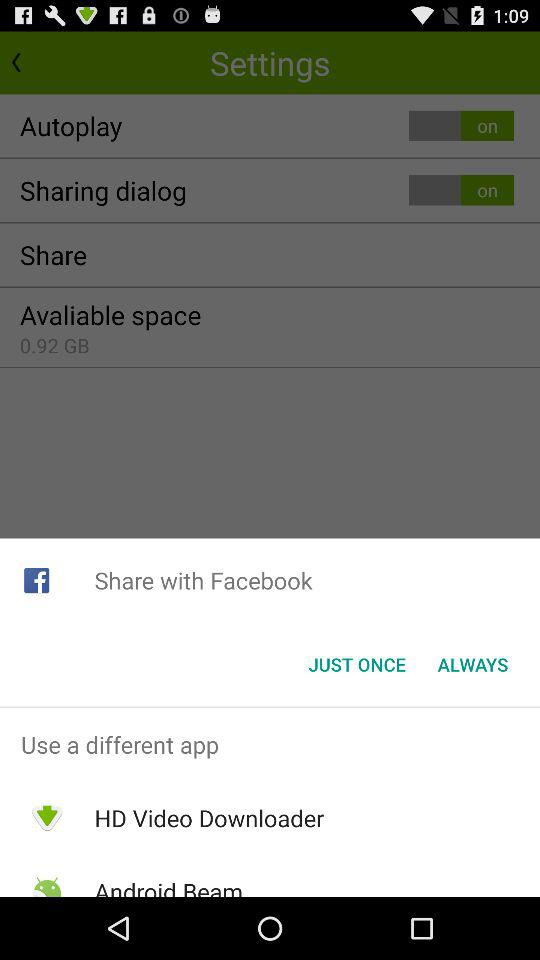What is the status of the "Sharing dialog" setting? The status is "on". 